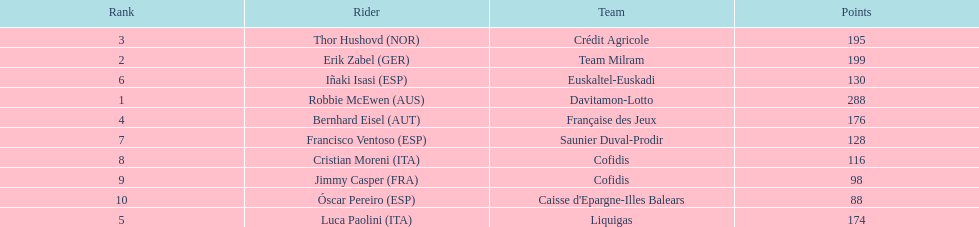How many points did robbie mcewen and cristian moreni score together? 404. Can you parse all the data within this table? {'header': ['Rank', 'Rider', 'Team', 'Points'], 'rows': [['3', 'Thor Hushovd\xa0(NOR)', 'Crédit Agricole', '195'], ['2', 'Erik Zabel\xa0(GER)', 'Team Milram', '199'], ['6', 'Iñaki Isasi\xa0(ESP)', 'Euskaltel-Euskadi', '130'], ['1', 'Robbie McEwen\xa0(AUS)', 'Davitamon-Lotto', '288'], ['4', 'Bernhard Eisel\xa0(AUT)', 'Française des Jeux', '176'], ['7', 'Francisco Ventoso\xa0(ESP)', 'Saunier Duval-Prodir', '128'], ['8', 'Cristian Moreni\xa0(ITA)', 'Cofidis', '116'], ['9', 'Jimmy Casper\xa0(FRA)', 'Cofidis', '98'], ['10', 'Óscar Pereiro\xa0(ESP)', "Caisse d'Epargne-Illes Balears", '88'], ['5', 'Luca Paolini\xa0(ITA)', 'Liquigas', '174']]} 